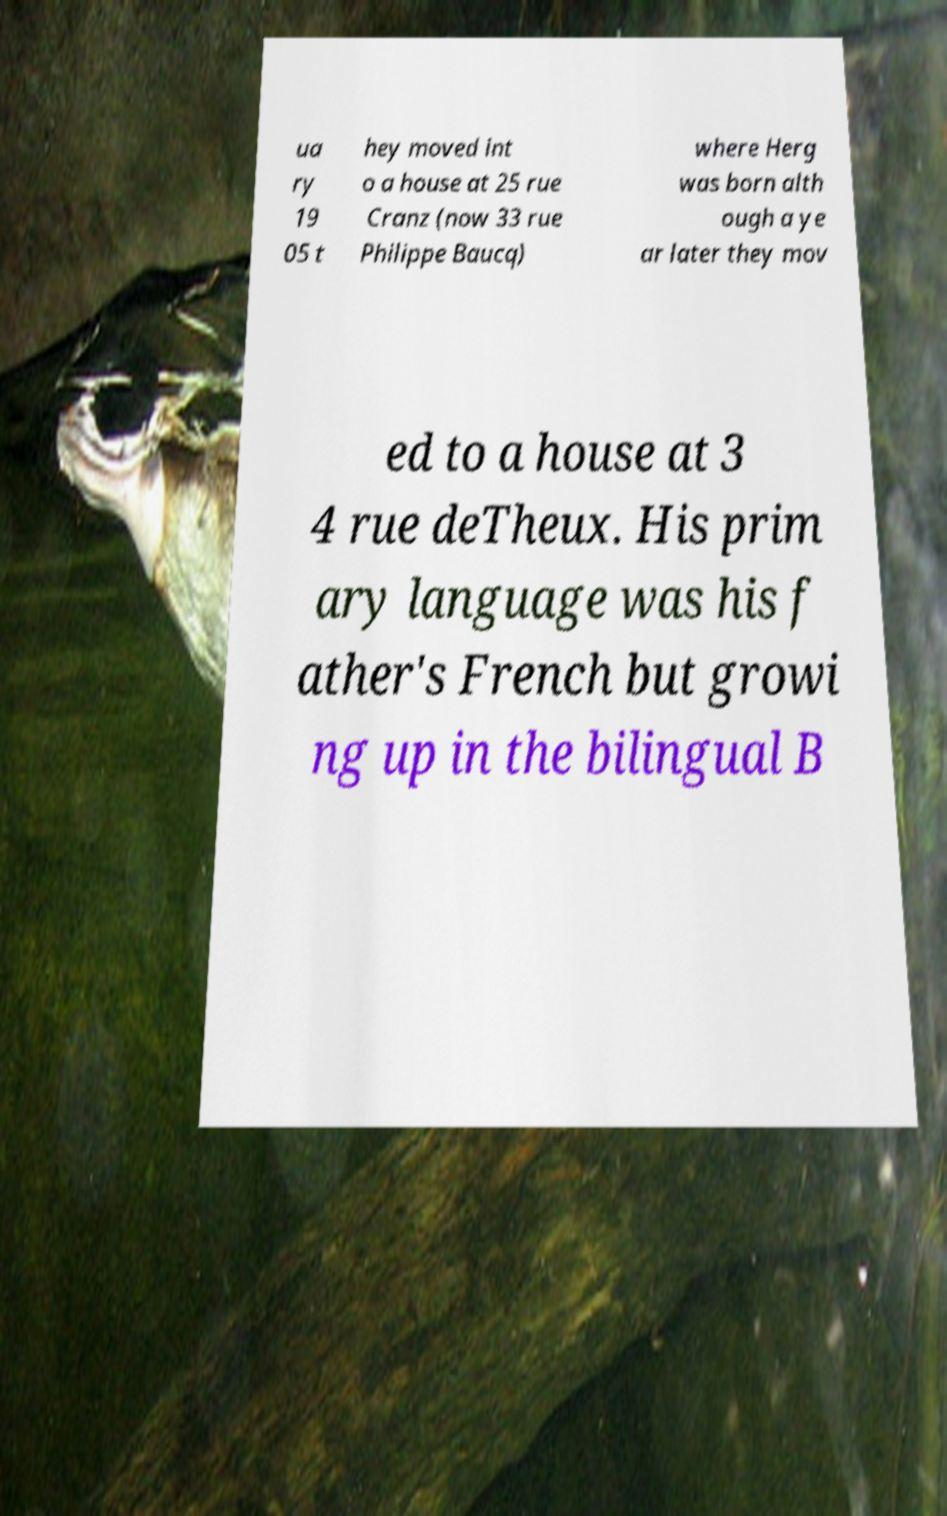For documentation purposes, I need the text within this image transcribed. Could you provide that? ua ry 19 05 t hey moved int o a house at 25 rue Cranz (now 33 rue Philippe Baucq) where Herg was born alth ough a ye ar later they mov ed to a house at 3 4 rue deTheux. His prim ary language was his f ather's French but growi ng up in the bilingual B 